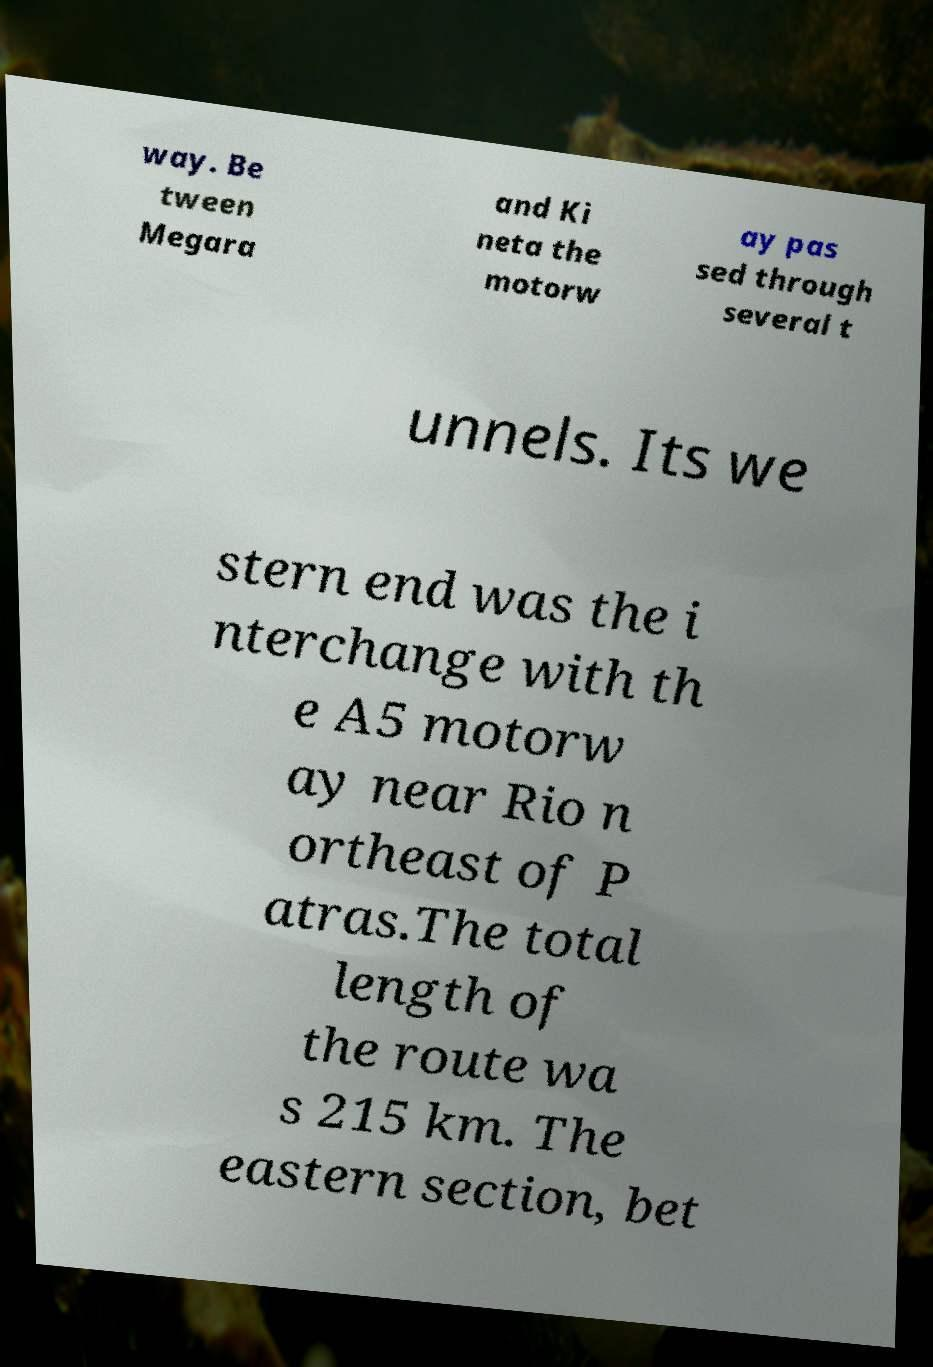Can you accurately transcribe the text from the provided image for me? way. Be tween Megara and Ki neta the motorw ay pas sed through several t unnels. Its we stern end was the i nterchange with th e A5 motorw ay near Rio n ortheast of P atras.The total length of the route wa s 215 km. The eastern section, bet 